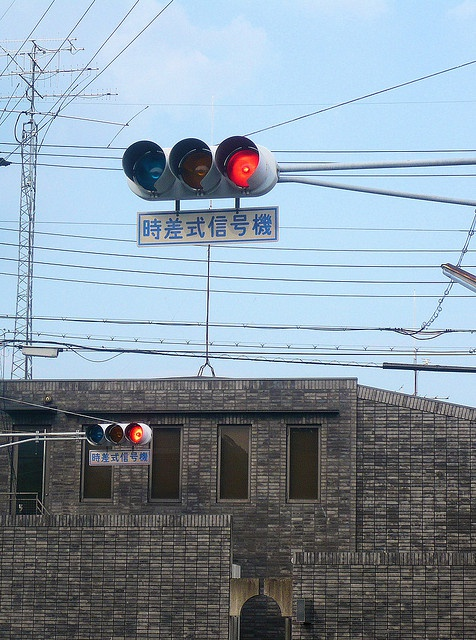Describe the objects in this image and their specific colors. I can see traffic light in lightblue, black, navy, gray, and blue tones and traffic light in lightblue, black, gray, lightgray, and navy tones in this image. 